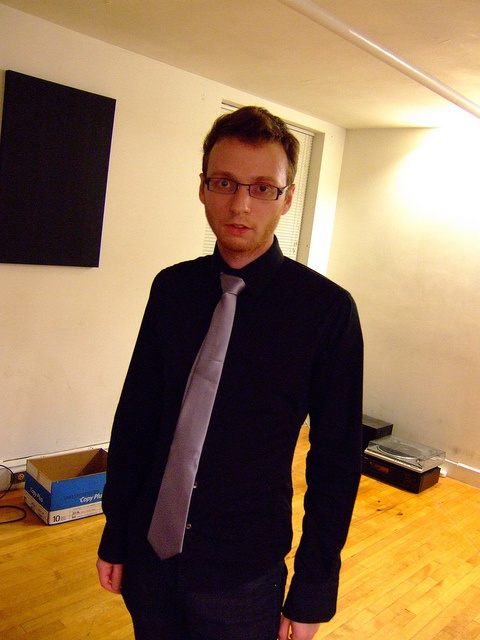Describe the objects in this image and their specific colors. I can see people in olive, black, maroon, and brown tones, tv in olive, black, and tan tones, and tie in olive, brown, maroon, purple, and black tones in this image. 